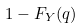Convert formula to latex. <formula><loc_0><loc_0><loc_500><loc_500>1 - F _ { Y } ( q )</formula> 